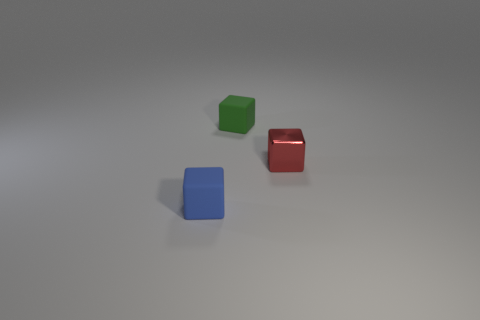Add 2 tiny blue cubes. How many objects exist? 5 Subtract all blue rubber blocks. How many blocks are left? 2 Subtract all red cubes. How many cubes are left? 2 Subtract 1 blocks. How many blocks are left? 2 Subtract all purple blocks. Subtract all blue spheres. How many blocks are left? 3 Subtract all gray balls. How many blue blocks are left? 1 Add 3 red objects. How many red objects exist? 4 Subtract 0 yellow spheres. How many objects are left? 3 Subtract all tiny cyan matte cylinders. Subtract all tiny objects. How many objects are left? 0 Add 2 tiny green cubes. How many tiny green cubes are left? 3 